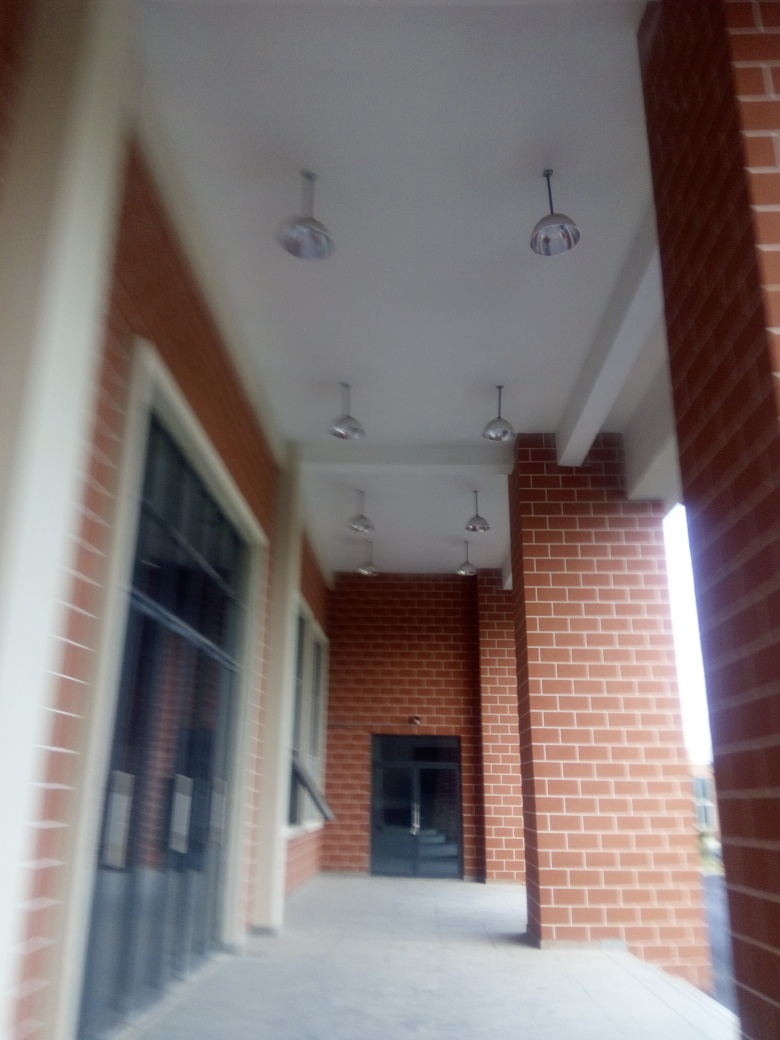Can you tell me about the lighting fixtures visible in the image? The image shows a series of identical pendant lights hanging from the ceiling. They bring a touch of modern elegance to the space and are likely designed to cast a diffuse light in the corridor. Is this type of lighting practical for such a space? Yes, pendant fixtures are a practical choice for corridors like this, as they provide sufficient illumination while also contributing to the ambience of the space. 